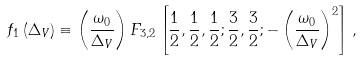Convert formula to latex. <formula><loc_0><loc_0><loc_500><loc_500>f _ { 1 } \left ( \Delta _ { V } \right ) \equiv \left ( \frac { \omega _ { 0 } } { \Delta _ { V } } \right ) F _ { 3 , 2 } \left [ \frac { 1 } { 2 } , \frac { 1 } { 2 } , \frac { 1 } { 2 } ; \frac { 3 } { 2 } , \frac { 3 } { 2 } ; - \left ( \frac { \omega _ { 0 } } { \Delta _ { V } } \right ) ^ { 2 } \right ] ,</formula> 